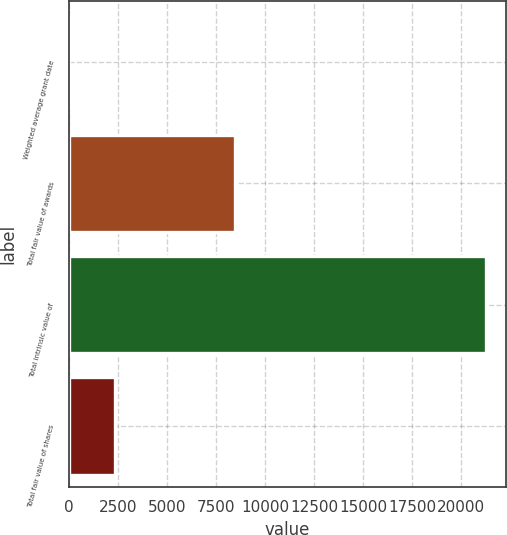Convert chart to OTSL. <chart><loc_0><loc_0><loc_500><loc_500><bar_chart><fcel>Weighted average grant date<fcel>Total fair value of awards<fcel>Total intrinsic value of<fcel>Total fair value of shares<nl><fcel>11.61<fcel>8492<fcel>21234<fcel>2359<nl></chart> 